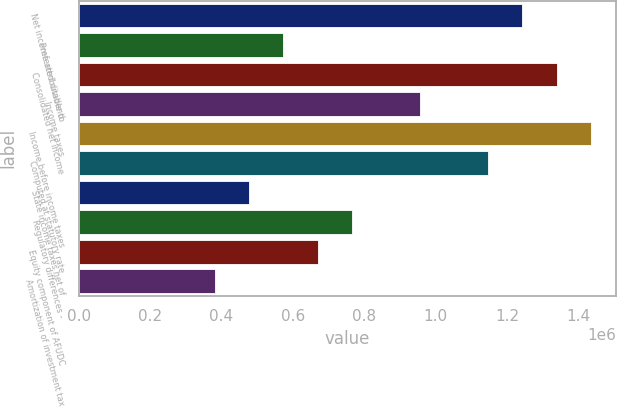<chart> <loc_0><loc_0><loc_500><loc_500><bar_chart><fcel>Net income attributable to<fcel>Preferred dividend<fcel>Consolidated net income<fcel>Income taxes<fcel>Income before income taxes<fcel>Computed at statutory rate<fcel>State income taxes net of<fcel>Regulatory differences -<fcel>Equity component of AFUDC<fcel>Amortization of investment tax<nl><fcel>1.24351e+06<fcel>573941<fcel>1.33916e+06<fcel>956553<fcel>1.43482e+06<fcel>1.14786e+06<fcel>478288<fcel>765247<fcel>669594<fcel>382635<nl></chart> 